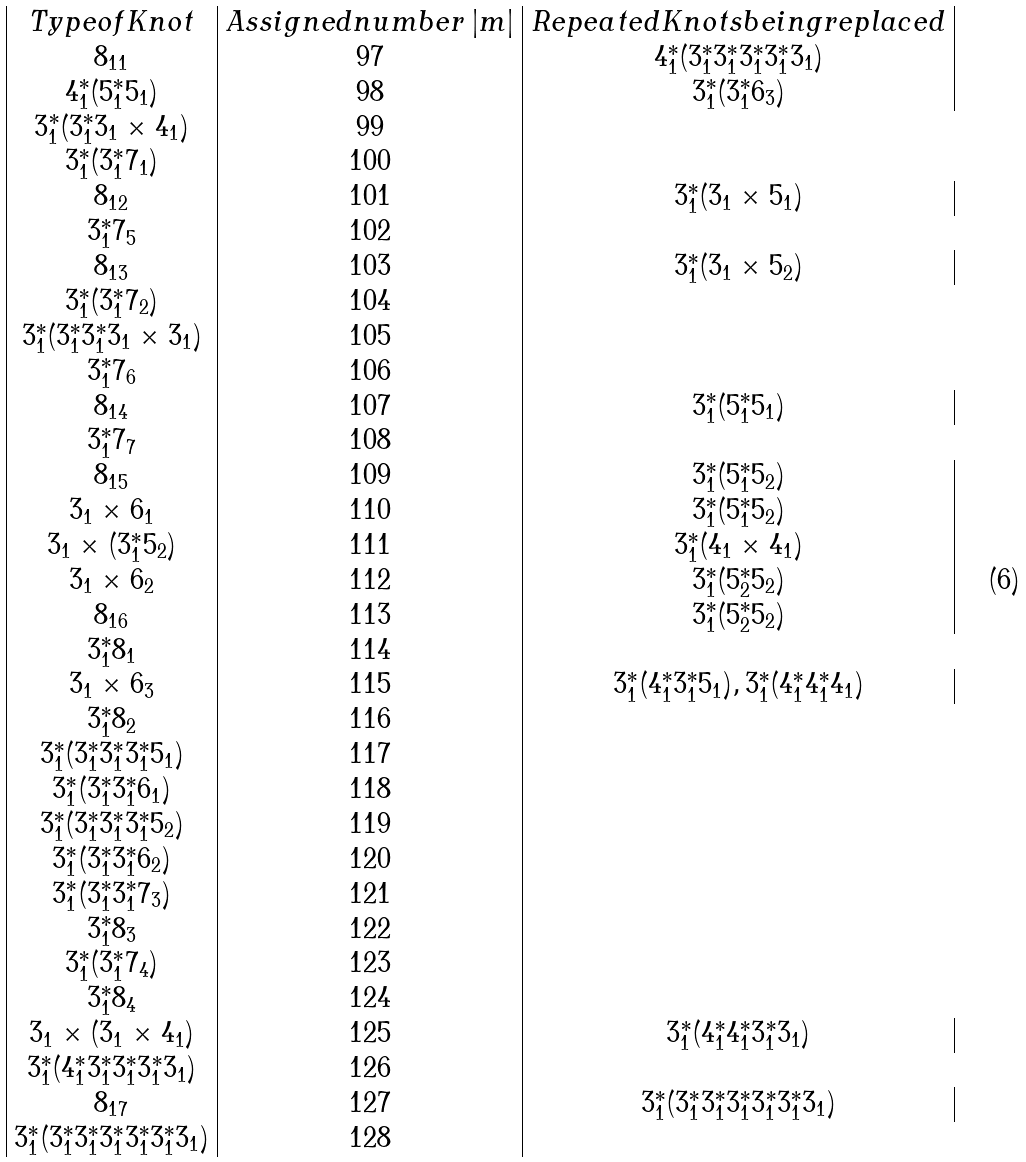Convert formula to latex. <formula><loc_0><loc_0><loc_500><loc_500>\begin{array} { | c | c | c | } T y p e o f K n o t & A s s i g n e d n u m b e r \, | m | & R e p e a t e d K n o t s b e i n g r e p l a c e d \\ { 8 _ { 1 1 } } & 9 7 & { 4 _ { 1 } ^ { * } ( 3 _ { 1 } ^ { * } 3 _ { 1 } ^ { * } 3 _ { 1 } ^ { * } 3 _ { 1 } ^ { * } 3 _ { 1 } ) } \\ { 4 _ { 1 } ^ { * } ( 5 _ { 1 } ^ { * } 5 _ { 1 } ) } & 9 8 & { 3 _ { 1 } ^ { * } ( 3 _ { 1 } ^ { * } 6 _ { 3 } ) } \\ { 3 _ { 1 } ^ { * } ( 3 _ { 1 } ^ { * } 3 _ { 1 } \times 4 _ { 1 } ) } & 9 9 \\ { 3 _ { 1 } ^ { * } ( 3 _ { 1 } ^ { * } 7 _ { 1 } ) } & 1 0 0 \\ { 8 _ { 1 2 } } & 1 0 1 & { 3 _ { 1 } ^ { * } ( 3 _ { 1 } \times 5 _ { 1 } ) } \\ { 3 _ { 1 } ^ { * } 7 _ { 5 } } & 1 0 2 \\ { 8 _ { 1 3 } } & 1 0 3 & { 3 _ { 1 } ^ { * } ( 3 _ { 1 } \times 5 _ { 2 } ) } \\ { 3 _ { 1 } ^ { * } ( 3 _ { 1 } ^ { * } 7 _ { 2 } ) } & 1 0 4 \\ { 3 _ { 1 } ^ { * } ( 3 _ { 1 } ^ { * } 3 _ { 1 } ^ { * } 3 _ { 1 } \times 3 _ { 1 } ) } & 1 0 5 \\ { 3 _ { 1 } ^ { * } 7 _ { 6 } } & 1 0 6 \\ { 8 _ { 1 4 } } & 1 0 7 & { 3 _ { 1 } ^ { * } ( 5 _ { 1 } ^ { * } 5 _ { 1 } ) } \\ { 3 _ { 1 } ^ { * } 7 _ { 7 } } & 1 0 8 \\ { 8 _ { 1 5 } } & 1 0 9 & { 3 _ { 1 } ^ { * } ( 5 _ { 1 } ^ { * } 5 _ { 2 } ) } \\ { 3 _ { 1 } \times 6 _ { 1 } } & 1 1 0 & { 3 _ { 1 } ^ { * } ( 5 _ { 1 } ^ { * } 5 _ { 2 } ) } \\ { 3 _ { 1 } \times ( 3 _ { 1 } ^ { * } 5 _ { 2 } ) } & 1 1 1 & { 3 _ { 1 } ^ { * } ( 4 _ { 1 } \times 4 _ { 1 } ) } \\ { 3 _ { 1 } \times 6 _ { 2 } } & 1 1 2 & { 3 _ { 1 } ^ { * } ( 5 _ { 2 } ^ { * } 5 _ { 2 } ) } \\ { 8 _ { 1 6 } } & 1 1 3 & { 3 _ { 1 } ^ { * } ( 5 _ { 2 } ^ { * } 5 _ { 2 } ) } \\ { 3 _ { 1 } ^ { * } 8 _ { 1 } } & 1 1 4 \\ { 3 _ { 1 } \times 6 _ { 3 } } & 1 1 5 & { 3 _ { 1 } ^ { * } ( 4 _ { 1 } ^ { * } 3 _ { 1 } ^ { * } 5 _ { 1 } ) , 3 _ { 1 } ^ { * } ( 4 _ { 1 } ^ { * } 4 _ { 1 } ^ { * } 4 _ { 1 } ) } \\ { 3 _ { 1 } ^ { * } 8 _ { 2 } } & 1 1 6 \\ { 3 _ { 1 } ^ { * } ( 3 _ { 1 } ^ { * } 3 _ { 1 } ^ { * } 3 _ { 1 } ^ { * } 5 _ { 1 } ) } & 1 1 7 \\ { 3 _ { 1 } ^ { * } ( 3 _ { 1 } ^ { * } 3 _ { 1 } ^ { * } 6 _ { 1 } ) } & 1 1 8 \\ { 3 _ { 1 } ^ { * } ( 3 _ { 1 } ^ { * } 3 _ { 1 } ^ { * } 3 _ { 1 } ^ { * } 5 _ { 2 } ) } & 1 1 9 \\ { 3 _ { 1 } ^ { * } ( 3 _ { 1 } ^ { * } 3 _ { 1 } ^ { * } 6 _ { 2 } ) } & 1 2 0 \\ { 3 _ { 1 } ^ { * } ( 3 _ { 1 } ^ { * } 3 _ { 1 } ^ { * } 7 _ { 3 } ) } & 1 2 1 \\ { 3 _ { 1 } ^ { * } 8 _ { 3 } } & 1 2 2 \\ { 3 _ { 1 } ^ { * } ( 3 _ { 1 } ^ { * } 7 _ { 4 } ) } & 1 2 3 \\ { 3 _ { 1 } ^ { * } 8 _ { 4 } } & 1 2 4 \\ { 3 _ { 1 } \times ( 3 _ { 1 } \times 4 _ { 1 } ) } & 1 2 5 & { 3 _ { 1 } ^ { * } ( 4 _ { 1 } ^ { * } 4 _ { 1 } ^ { * } 3 _ { 1 } ^ { * } 3 _ { 1 } ) } \\ { 3 _ { 1 } ^ { * } ( 4 _ { 1 } ^ { * } 3 _ { 1 } ^ { * } 3 _ { 1 } ^ { * } 3 _ { 1 } ^ { * } 3 _ { 1 } ) } & 1 2 6 \\ { 8 _ { 1 7 } } & 1 2 7 & { 3 _ { 1 } ^ { * } ( 3 _ { 1 } ^ { * } 3 _ { 1 } ^ { * } 3 _ { 1 } ^ { * } 3 _ { 1 } ^ { * } 3 _ { 1 } ^ { * } 3 _ { 1 } ) } \\ { 3 _ { 1 } ^ { * } ( 3 _ { 1 } ^ { * } 3 _ { 1 } ^ { * } 3 _ { 1 } ^ { * } 3 _ { 1 } ^ { * } 3 _ { 1 } ^ { * } 3 _ { 1 } ) } & 1 2 8 \\ \end{array}</formula> 